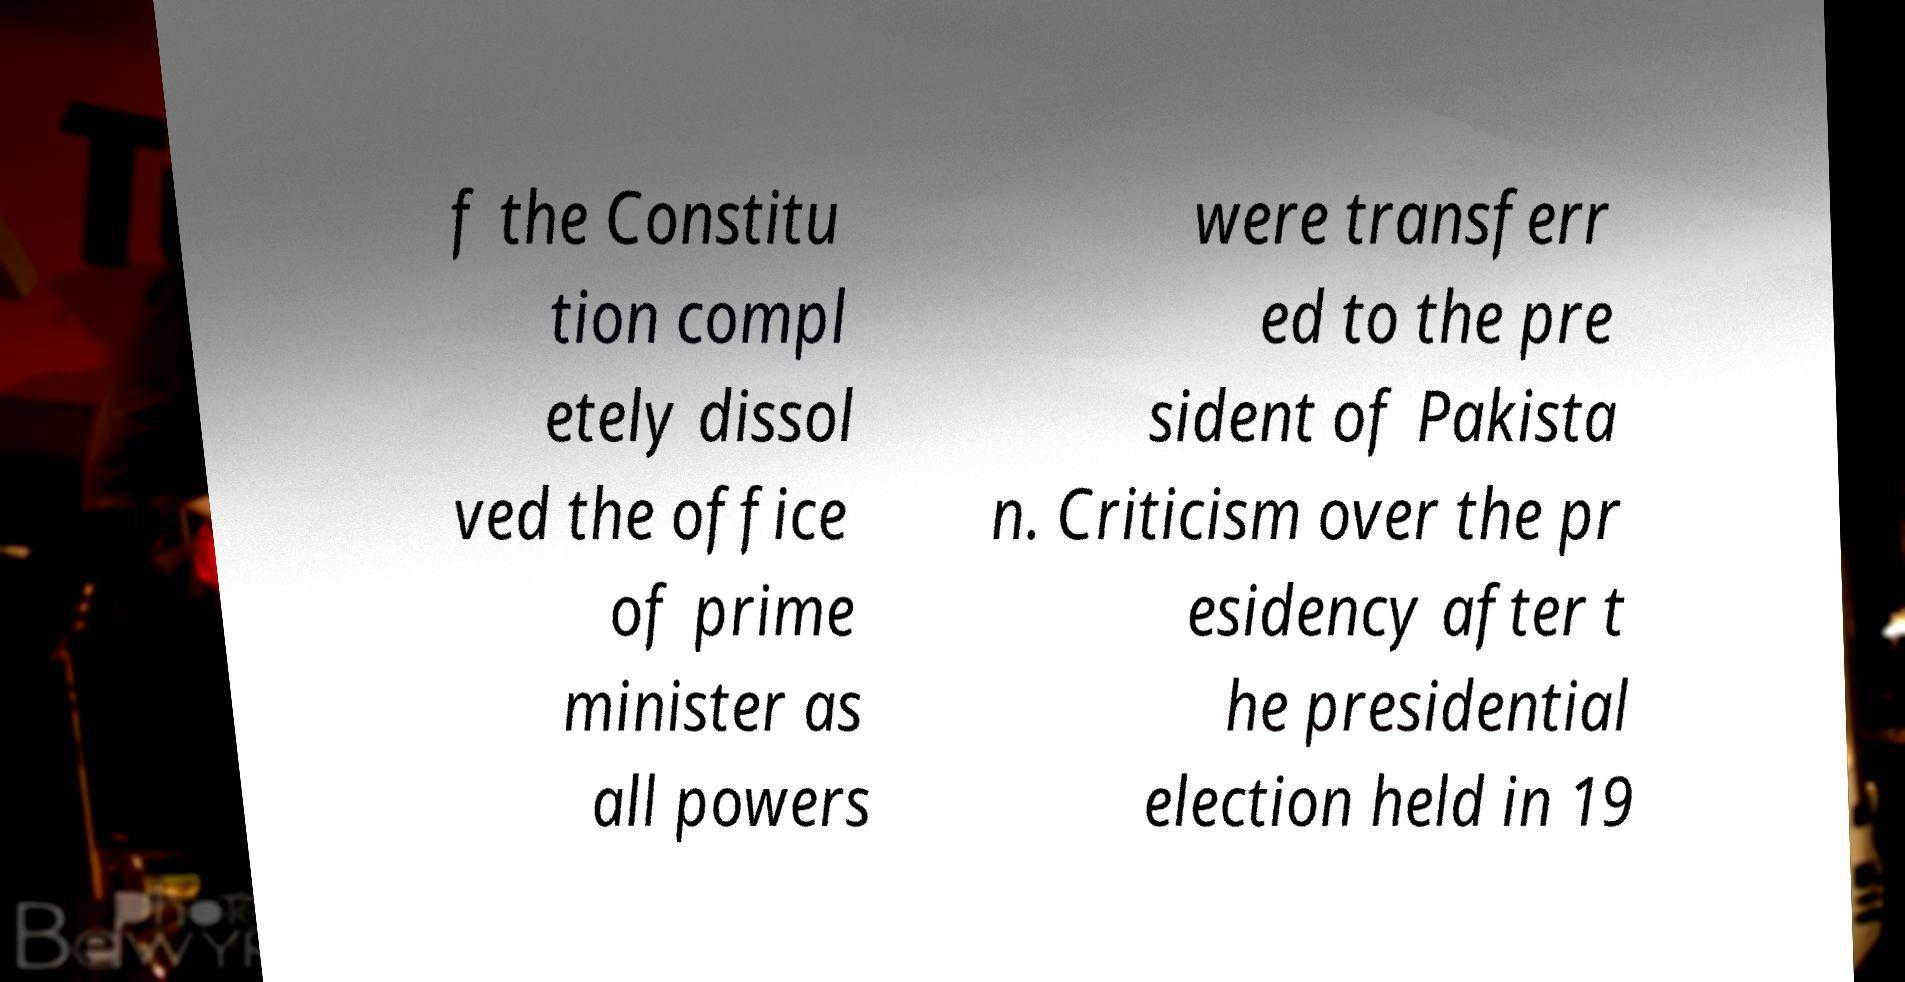For documentation purposes, I need the text within this image transcribed. Could you provide that? f the Constitu tion compl etely dissol ved the office of prime minister as all powers were transferr ed to the pre sident of Pakista n. Criticism over the pr esidency after t he presidential election held in 19 